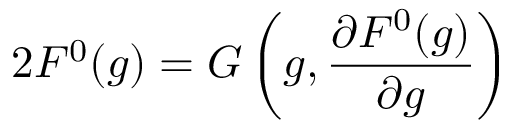Convert formula to latex. <formula><loc_0><loc_0><loc_500><loc_500>2 F ^ { 0 } ( g ) = G \left ( g , \frac { \partial F ^ { 0 } ( g ) } { \partial g } \right )</formula> 